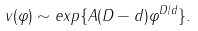Convert formula to latex. <formula><loc_0><loc_0><loc_500><loc_500>v ( \varphi ) \sim e x p \{ A ( D - d ) \varphi ^ { D / d } \} .</formula> 